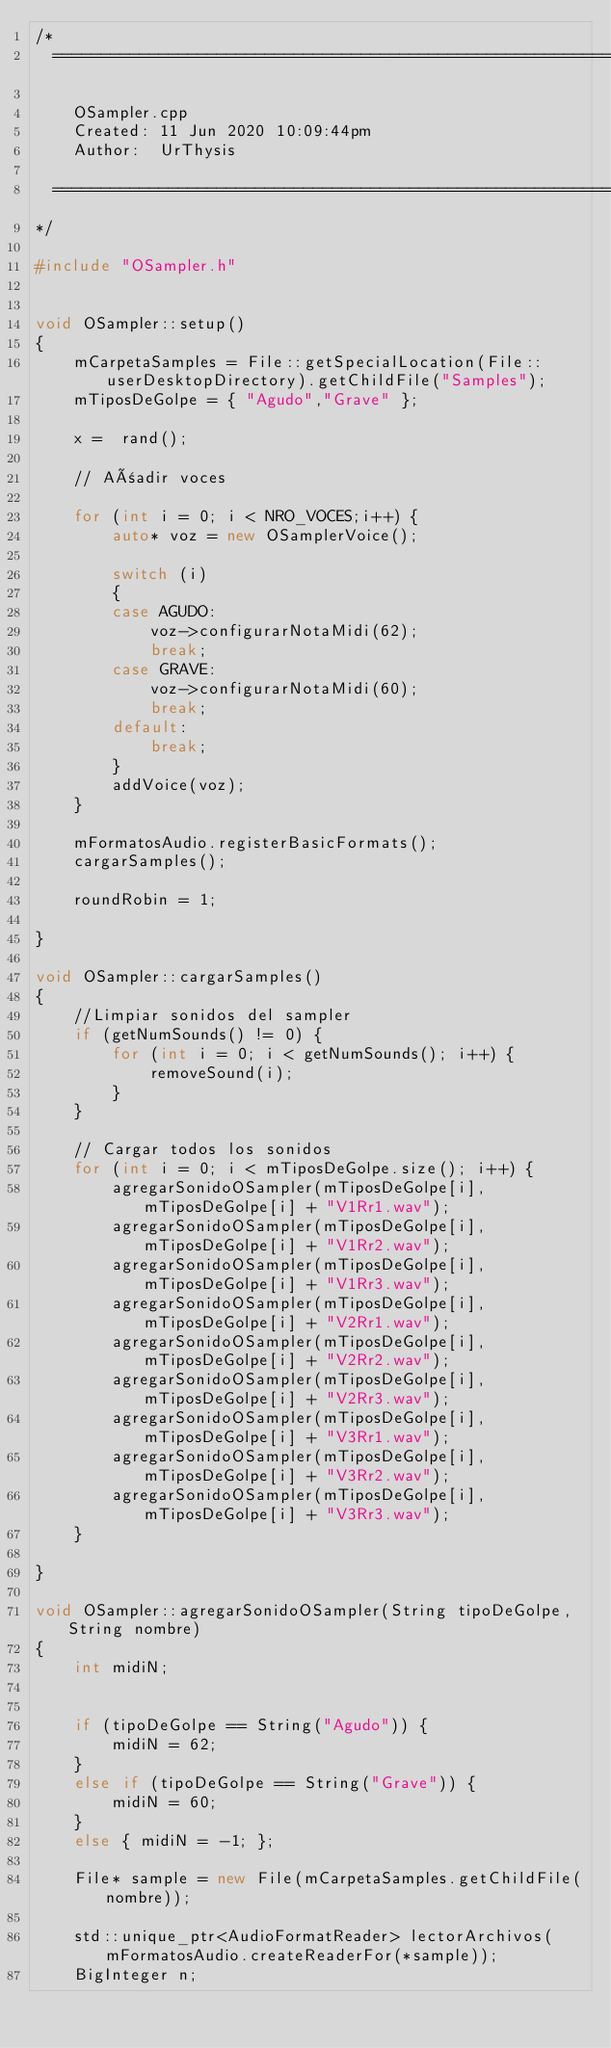Convert code to text. <code><loc_0><loc_0><loc_500><loc_500><_C++_>/*
  ==============================================================================

    OSampler.cpp
    Created: 11 Jun 2020 10:09:44pm
    Author:  UrThysis

  ==============================================================================
*/

#include "OSampler.h"


void OSampler::setup()
{
    mCarpetaSamples = File::getSpecialLocation(File::userDesktopDirectory).getChildFile("Samples");
    mTiposDeGolpe = { "Agudo","Grave" };

    x =  rand();

    // Añadir voces 

    for (int i = 0; i < NRO_VOCES;i++) {
        auto* voz = new OSamplerVoice();

        switch (i)
        {
        case AGUDO:
            voz->configurarNotaMidi(62);
            break;
        case GRAVE:
            voz->configurarNotaMidi(60);
            break;
        default:
            break;
        }
        addVoice(voz);
    }

    mFormatosAudio.registerBasicFormats();
    cargarSamples();   

    roundRobin = 1;
    
} 

void OSampler::cargarSamples()
{
    //Limpiar sonidos del sampler
    if (getNumSounds() != 0) {
        for (int i = 0; i < getNumSounds(); i++) {
            removeSound(i);
        }
    }

    // Cargar todos los sonidos   
    for (int i = 0; i < mTiposDeGolpe.size(); i++) {
        agregarSonidoOSampler(mTiposDeGolpe[i], mTiposDeGolpe[i] + "V1Rr1.wav");
        agregarSonidoOSampler(mTiposDeGolpe[i], mTiposDeGolpe[i] + "V1Rr2.wav");
        agregarSonidoOSampler(mTiposDeGolpe[i], mTiposDeGolpe[i] + "V1Rr3.wav");
        agregarSonidoOSampler(mTiposDeGolpe[i], mTiposDeGolpe[i] + "V2Rr1.wav");
        agregarSonidoOSampler(mTiposDeGolpe[i], mTiposDeGolpe[i] + "V2Rr2.wav");
        agregarSonidoOSampler(mTiposDeGolpe[i], mTiposDeGolpe[i] + "V2Rr3.wav");
        agregarSonidoOSampler(mTiposDeGolpe[i], mTiposDeGolpe[i] + "V3Rr1.wav");
        agregarSonidoOSampler(mTiposDeGolpe[i], mTiposDeGolpe[i] + "V3Rr2.wav");
        agregarSonidoOSampler(mTiposDeGolpe[i], mTiposDeGolpe[i] + "V3Rr3.wav");
    }
   
}

void OSampler::agregarSonidoOSampler(String tipoDeGolpe, String nombre)
{
    int midiN;

    
    if (tipoDeGolpe == String("Agudo")) {
        midiN = 62; 
    }
    else if (tipoDeGolpe == String("Grave")) {
        midiN = 60;
    }
    else { midiN = -1; };
 
    File* sample = new File(mCarpetaSamples.getChildFile(nombre));

    std::unique_ptr<AudioFormatReader> lectorArchivos(mFormatosAudio.createReaderFor(*sample));
    BigInteger n;</code> 